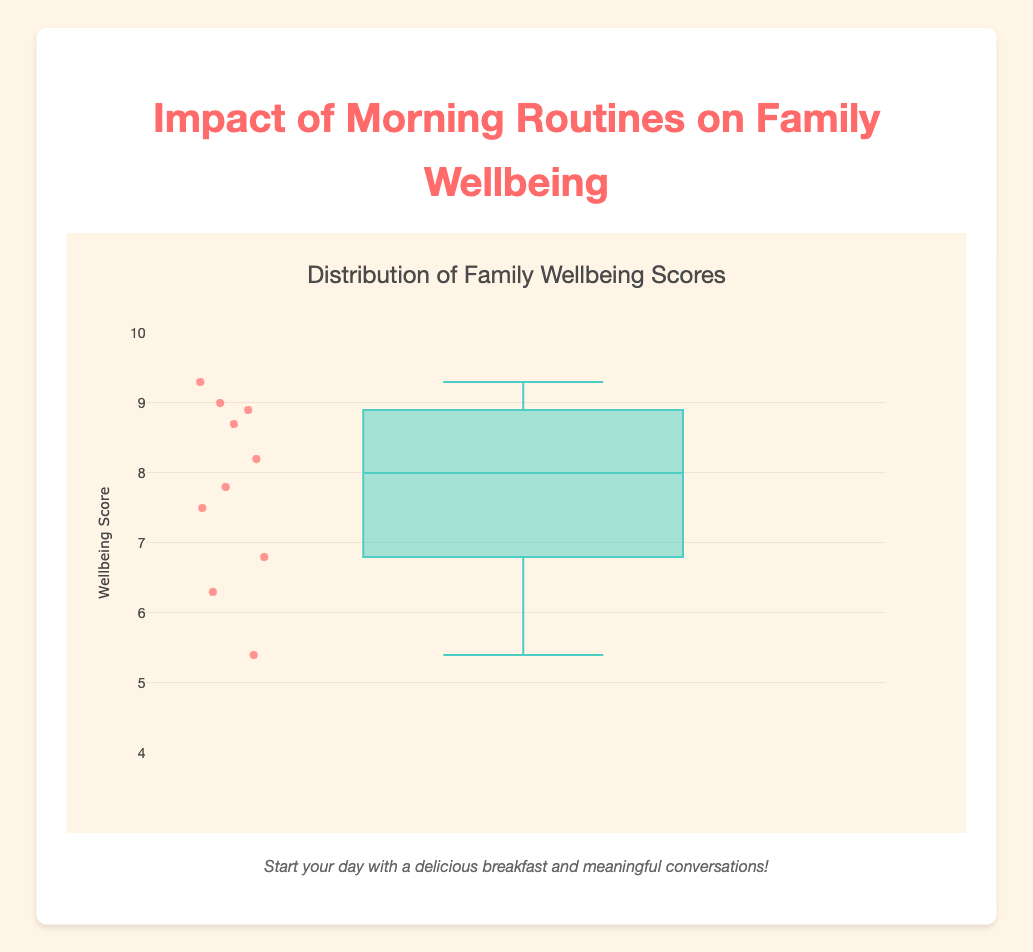Which household has the highest wellbeing score? Look for the highest data point on the y-axis. The hover text indicates which family each point corresponds to.
Answer: Jones Family What is the title of the chart? The title is usually at the top of the chart, displayed prominently.
Answer: Distribution of Family Wellbeing Scores Which routine is associated with the lowest wellbeing score? Identify the lowest data point on the y-axis and check the hover text to see which routine it corresponds to.
Answer: No Breakfast & Long Commute How many families have a wellbeing score above 8? Count the number of data points above the y-axis value of 8.
Answer: 6 What is the median wellbeing score of the households? The median value is the middle value of the data when arranged in order. In a box plot, it is marked by the line inside the box.
Answer: 8.05 (approximate value from visual inspection) Which family routine seems to have the most positive impact on wellbeing as per the box plot? Compare the wellbeing score points and determine which one is the highest.
Answer: Healthy Breakfast & Family Discussion How does the score of the "Early Breakfast & Exercise" routine compare to the "Quick Breakfast & School Preparation"? Find both routines on the y-axis and compare their scores.
Answer: Early Breakfast & Exercise is higher (8.2 vs 7.5) Is there a routine associated with a wellbeing score of exactly 6.0? Check the data points on the y-axis for a score of 6.0 and see the associated hover text for the routine.
Answer: No What is the difference in wellbeing scores between the Martinez Family and the Garcia Family? Subtract the wellbeing score of the Garcia Family from that of the Martinez Family (8.7 - 6.8).
Answer: 1.9 Which routine has a score closest to the median of all family wellbeing scores? Determine the median (8.05) and find the routine whose score is closest to this value.
Answer: Home Cooked Breakfast & Reading Time 